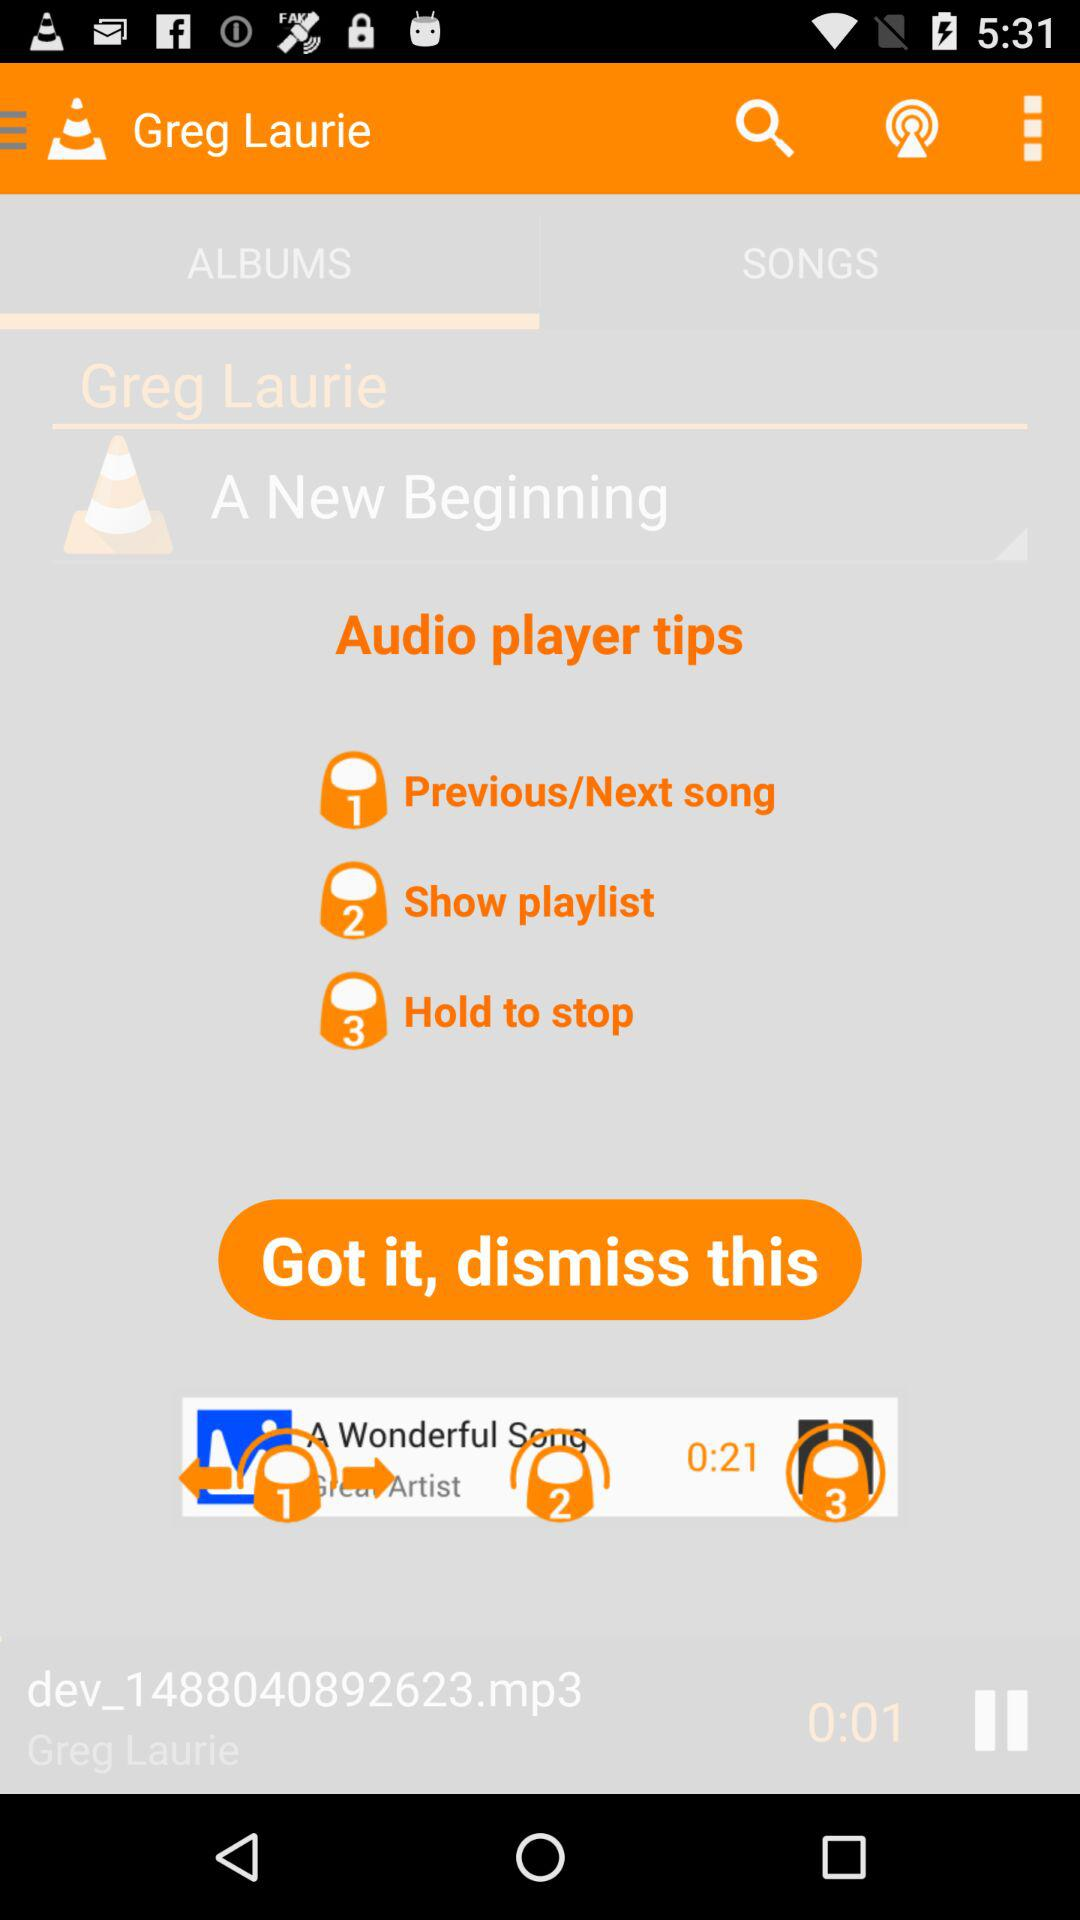What is the time duration of the song? The duration of the song is 0:01. 